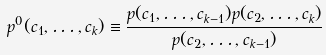<formula> <loc_0><loc_0><loc_500><loc_500>p ^ { 0 } ( c _ { 1 } , \dots , c _ { k } ) \equiv \frac { p ( c _ { 1 } , \dots , c _ { k - 1 } ) p ( c _ { 2 } , \dots , c _ { k } ) } { p ( c _ { 2 } , \dots , c _ { k - 1 } ) }</formula> 